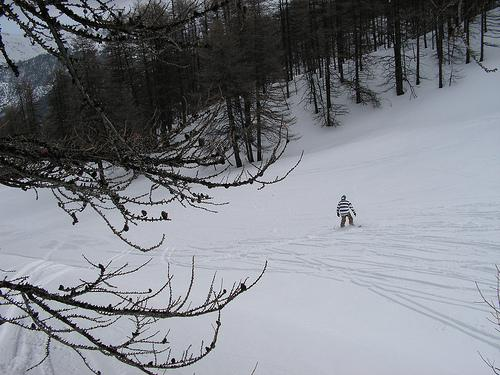Question: why was the picture taken?
Choices:
A. To show cars.
B. To capture the snowboarder.
C. To promote.
D. To make a calender.
Answer with the letter. Answer: B Question: where was the picture taken?
Choices:
A. On the mountain.
B. In the park.
C. At the zoo.
D. Outside in the snow.
Answer with the letter. Answer: D Question: what color are the trees?
Choices:
A. Green.
B. Brown.
C. Orange.
D. Purple.
Answer with the letter. Answer: B Question: what is the man doing?
Choices:
A. Snowboarding.
B. Snowmobiling.
C. Racing.
D. Running.
Answer with the letter. Answer: A 